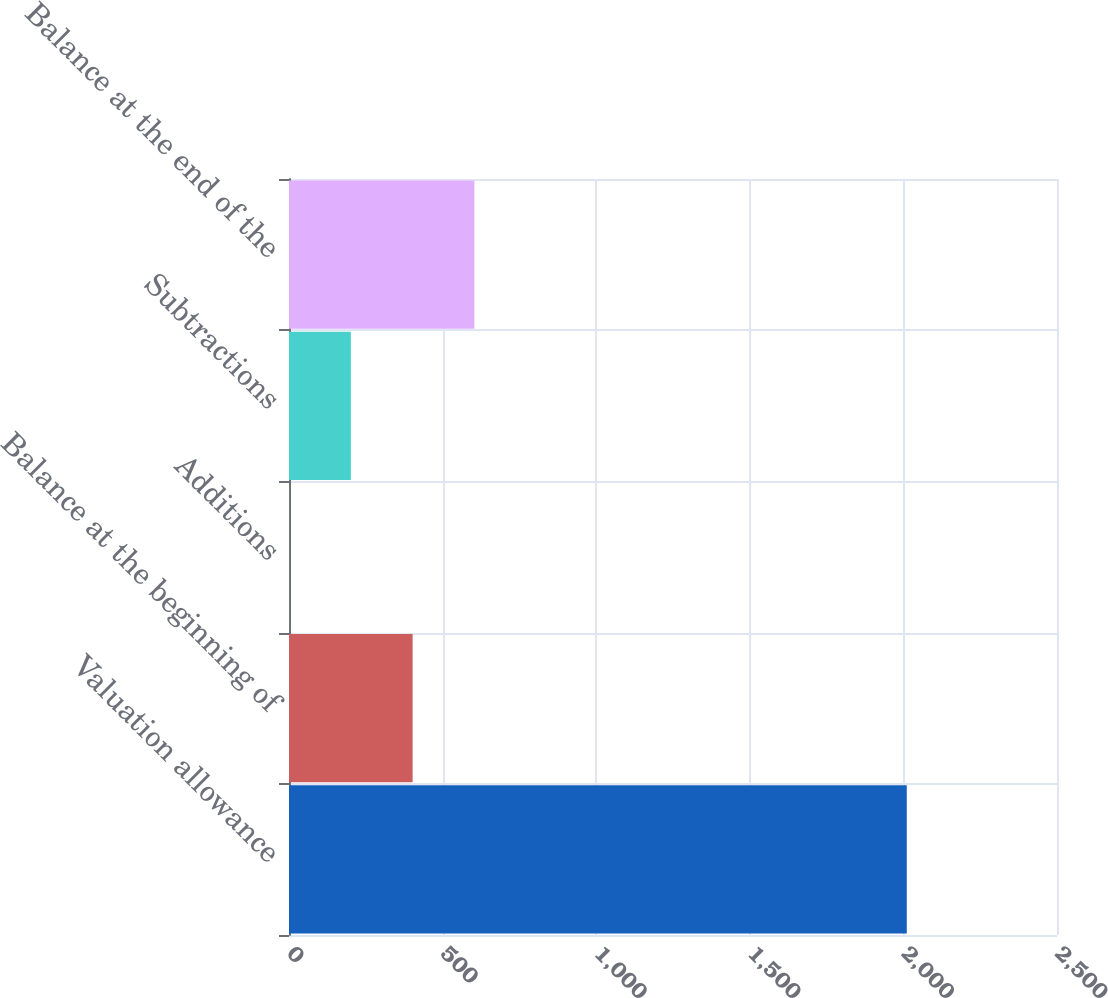Convert chart. <chart><loc_0><loc_0><loc_500><loc_500><bar_chart><fcel>Valuation allowance<fcel>Balance at the beginning of<fcel>Additions<fcel>Subtractions<fcel>Balance at the end of the<nl><fcel>2011<fcel>402.42<fcel>0.28<fcel>201.35<fcel>603.49<nl></chart> 